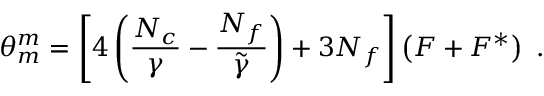<formula> <loc_0><loc_0><loc_500><loc_500>\theta _ { m } ^ { m } = \left [ 4 \left ( \frac { N _ { c } } { \gamma } - \frac { N _ { f } } { \tilde { \gamma } } \right ) + 3 N _ { f } \right ] \left ( F + F ^ { * } \right ) \ .</formula> 